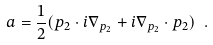Convert formula to latex. <formula><loc_0><loc_0><loc_500><loc_500>a = \frac { 1 } { 2 } ( p _ { 2 } \cdot i \nabla _ { p _ { 2 } } + i \nabla _ { p _ { 2 } } \cdot p _ { 2 } ) \ .</formula> 